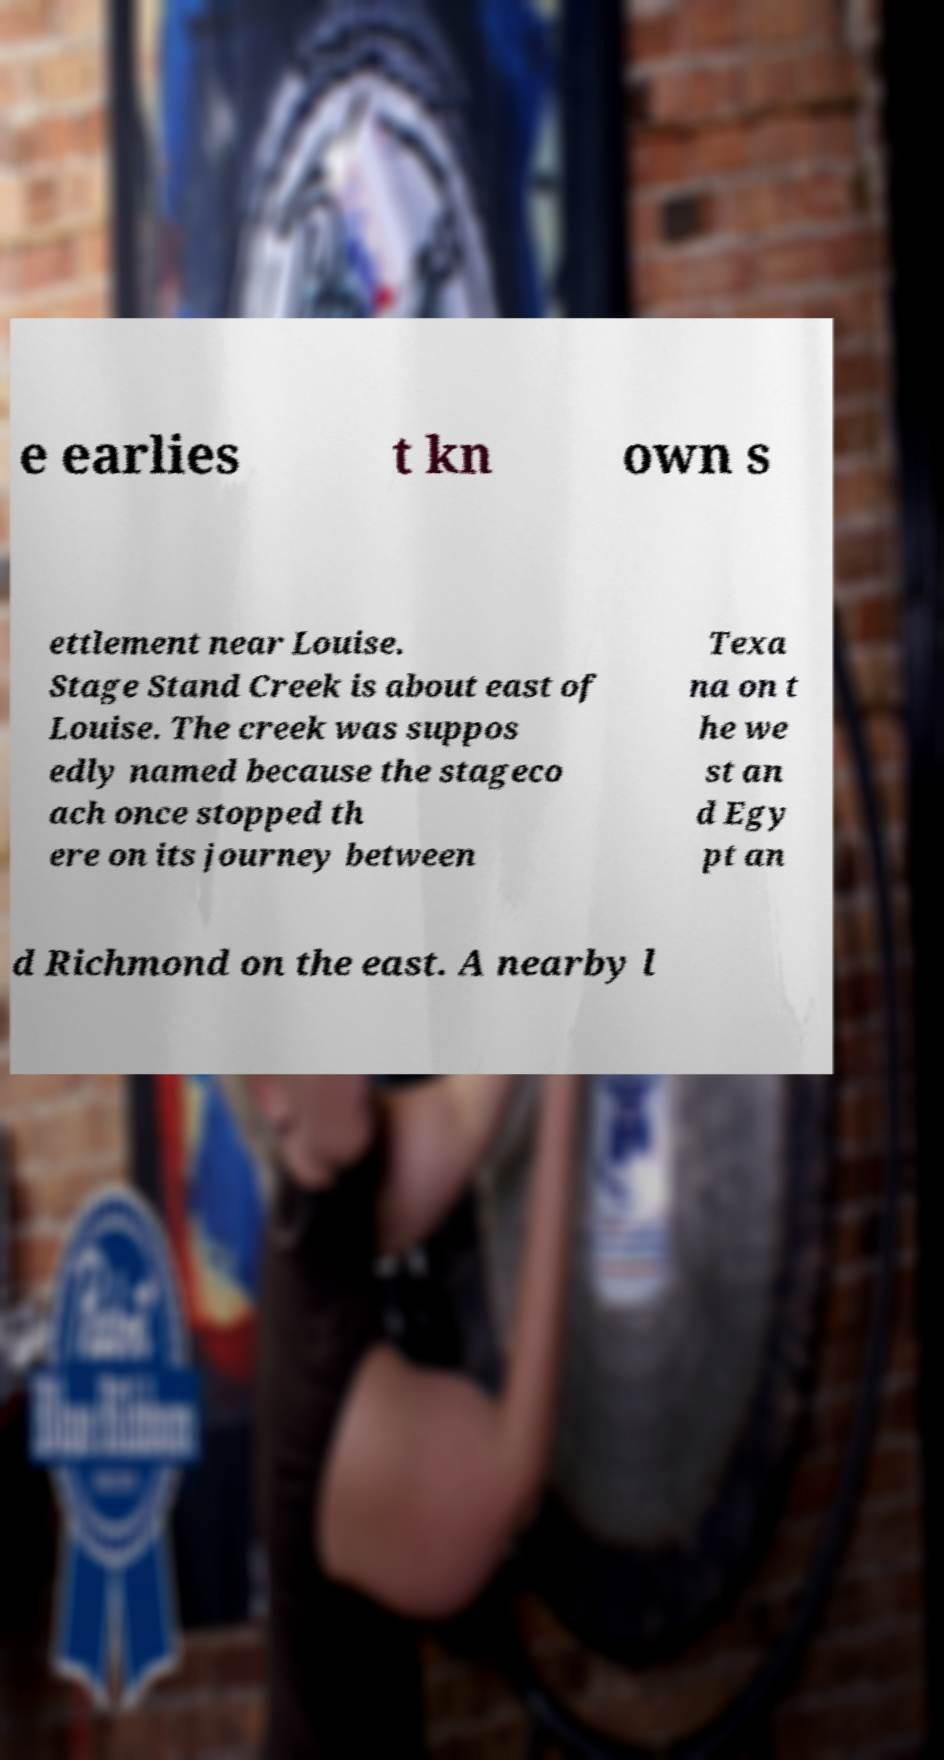There's text embedded in this image that I need extracted. Can you transcribe it verbatim? e earlies t kn own s ettlement near Louise. Stage Stand Creek is about east of Louise. The creek was suppos edly named because the stageco ach once stopped th ere on its journey between Texa na on t he we st an d Egy pt an d Richmond on the east. A nearby l 